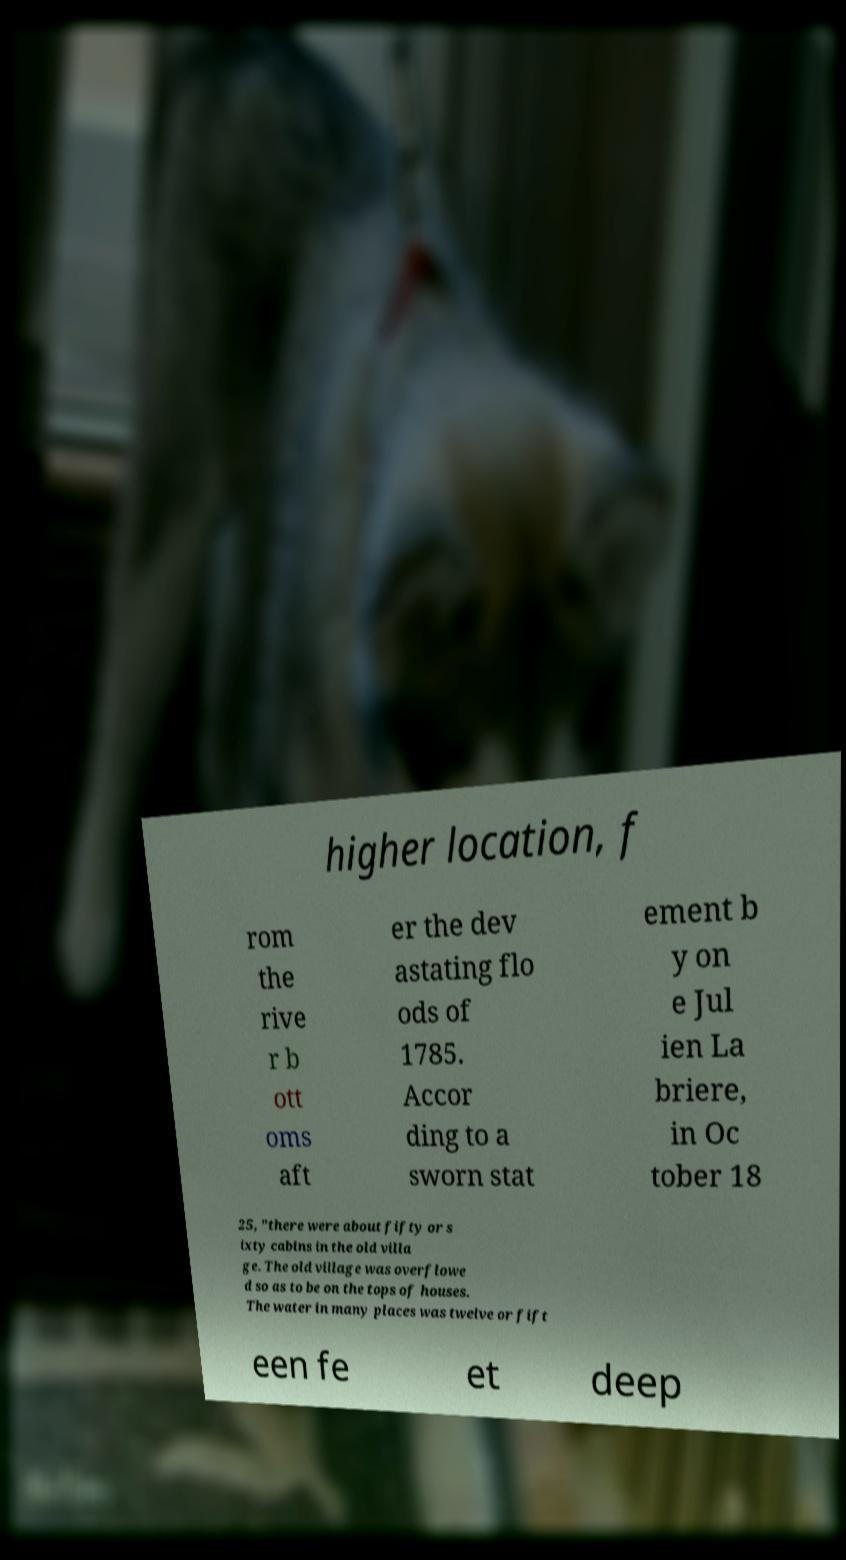Could you extract and type out the text from this image? higher location, f rom the rive r b ott oms aft er the dev astating flo ods of 1785. Accor ding to a sworn stat ement b y on e Jul ien La briere, in Oc tober 18 25, "there were about fifty or s ixty cabins in the old villa ge. The old village was overflowe d so as to be on the tops of houses. The water in many places was twelve or fift een fe et deep 